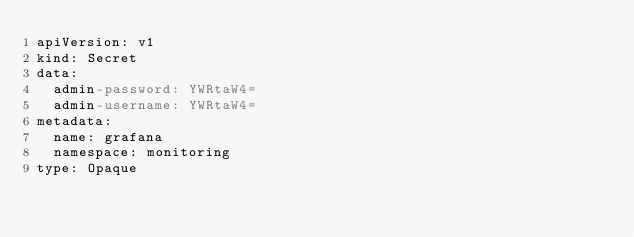<code> <loc_0><loc_0><loc_500><loc_500><_YAML_>apiVersion: v1
kind: Secret
data:
  admin-password: YWRtaW4=
  admin-username: YWRtaW4=
metadata:
  name: grafana
  namespace: monitoring
type: Opaque
</code> 